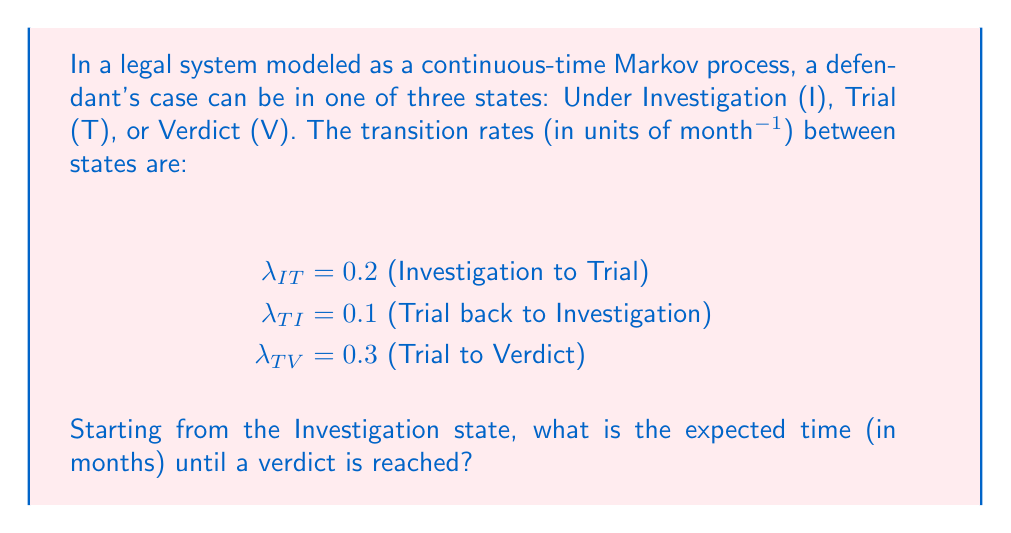Give your solution to this math problem. To solve this problem, we'll use the theory of absorbing Markov chains:

1) First, we identify the states:
   I (transient), T (transient), V (absorbing)

2) We can write the transition rate matrix Q:

   $$Q = \begin{bmatrix}
   -0.2 & 0.2 & 0 \\
   0.1 & -0.4 & 0.3 \\
   0 & 0 & 0
   \end{bmatrix}$$

3) We need to find the fundamental matrix N:
   $$N = (-Q_T)^{-1}$$
   where $Q_T$ is the submatrix of Q containing only the transient states:

   $$Q_T = \begin{bmatrix}
   -0.2 & 0.2 \\
   0.1 & -0.4
   \end{bmatrix}$$

4) Calculate $(-Q_T)^{-1}$:
   $$N = \begin{bmatrix}
   5.714 & 2.857 \\
   1.429 & 3.571
   \end{bmatrix}$$

5) The expected time to absorption (verdict) is the sum of the first row of N (since we start in state I):

   $E[T] = 5.714 + 2.857 = 8.571$ months
Answer: 8.571 months 